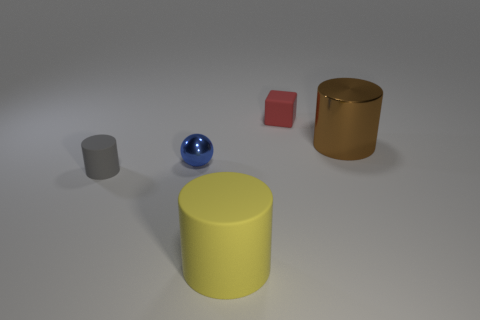Is the size of the blue ball the same as the gray cylinder?
Make the answer very short. Yes. There is a tiny rubber thing behind the big brown metallic cylinder; what shape is it?
Make the answer very short. Cube. There is a big object that is left of the small thing to the right of the small blue thing; what is its color?
Provide a short and direct response. Yellow. There is a rubber object that is to the left of the tiny blue metal ball; is it the same shape as the big thing behind the big yellow matte thing?
Your answer should be very brief. Yes. There is a red object that is the same size as the blue shiny ball; what shape is it?
Provide a succinct answer. Cube. There is a sphere that is the same material as the brown cylinder; what is its color?
Offer a terse response. Blue. There is a small gray matte object; is it the same shape as the large thing that is left of the large metal cylinder?
Provide a succinct answer. Yes. There is a blue ball that is the same size as the red rubber thing; what material is it?
Ensure brevity in your answer.  Metal. What shape is the object that is to the right of the yellow thing and on the left side of the large brown metal cylinder?
Your answer should be very brief. Cube. How many blue balls are the same material as the small gray thing?
Make the answer very short. 0. 